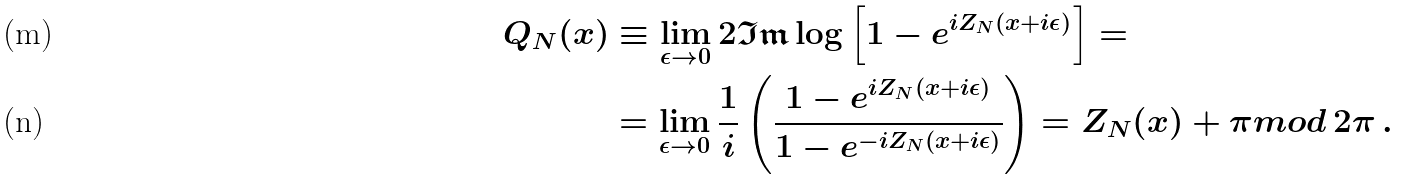Convert formula to latex. <formula><loc_0><loc_0><loc_500><loc_500>Q _ { N } ( x ) & \equiv \lim _ { \epsilon \rightarrow 0 } 2 \mathfrak { I m } \log \left [ 1 - e ^ { i Z _ { N } ( x + i \epsilon ) } \right ] = \\ & = \lim _ { \epsilon \rightarrow 0 } \frac { 1 } { i } \left ( \frac { 1 - e ^ { i Z _ { N } ( x + i \epsilon ) } } { 1 - e ^ { - i Z _ { N } ( x + i \epsilon ) } } \right ) = Z _ { N } ( x ) + \pi m o d \, 2 \pi \, .</formula> 